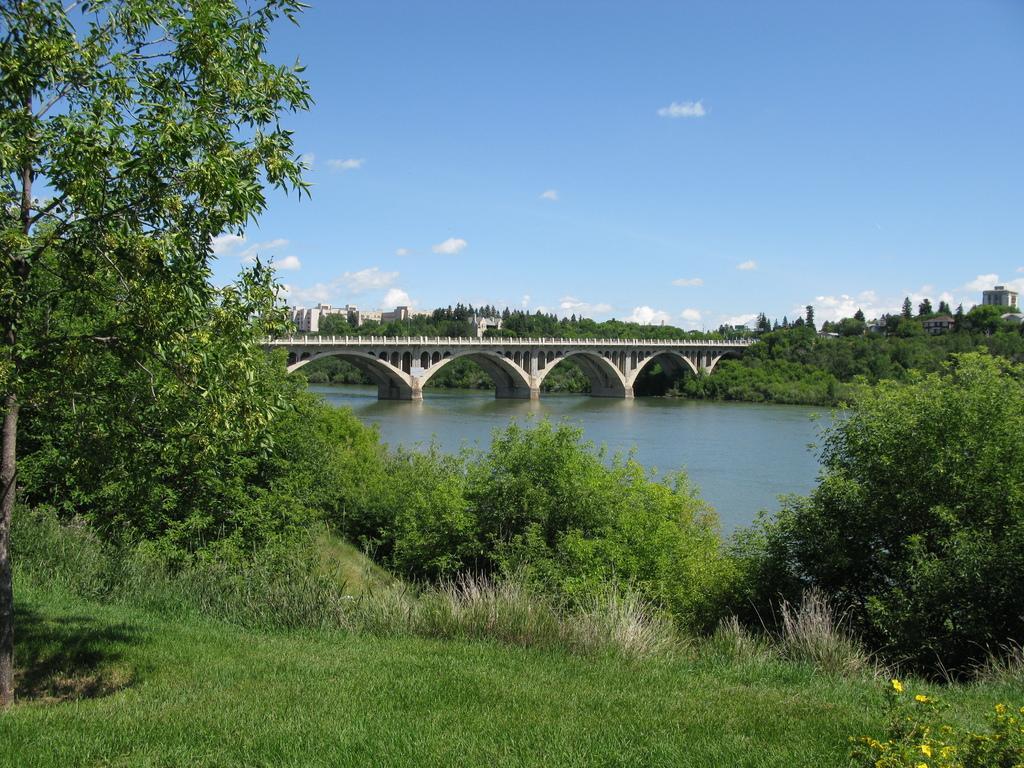How would you summarize this image in a sentence or two? In this image we can see a bridge above the water, there are some trees, buildings and grass, in the background we can see the sky with clouds. 